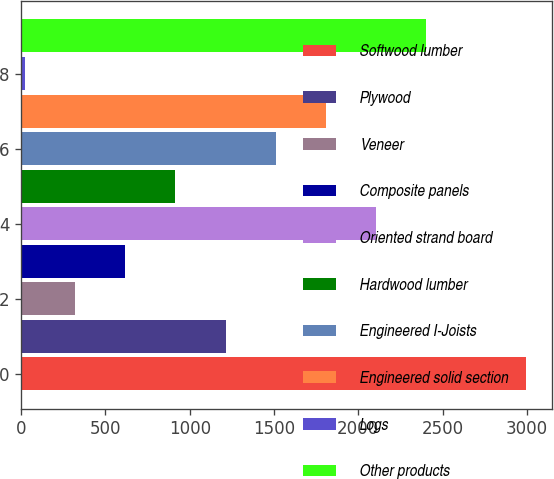<chart> <loc_0><loc_0><loc_500><loc_500><bar_chart><fcel>Softwood lumber<fcel>Plywood<fcel>Veneer<fcel>Composite panels<fcel>Oriented strand board<fcel>Hardwood lumber<fcel>Engineered I-Joists<fcel>Engineered solid section<fcel>Logs<fcel>Other products<nl><fcel>2997<fcel>1212.6<fcel>320.4<fcel>617.8<fcel>2104.8<fcel>915.2<fcel>1510<fcel>1807.4<fcel>23<fcel>2402.2<nl></chart> 